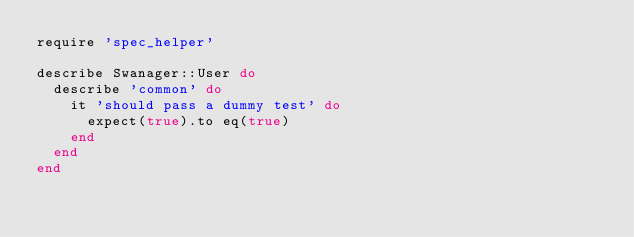Convert code to text. <code><loc_0><loc_0><loc_500><loc_500><_Ruby_>require 'spec_helper'

describe Swanager::User do
  describe 'common' do
    it 'should pass a dummy test' do
      expect(true).to eq(true)
    end
  end
end
</code> 